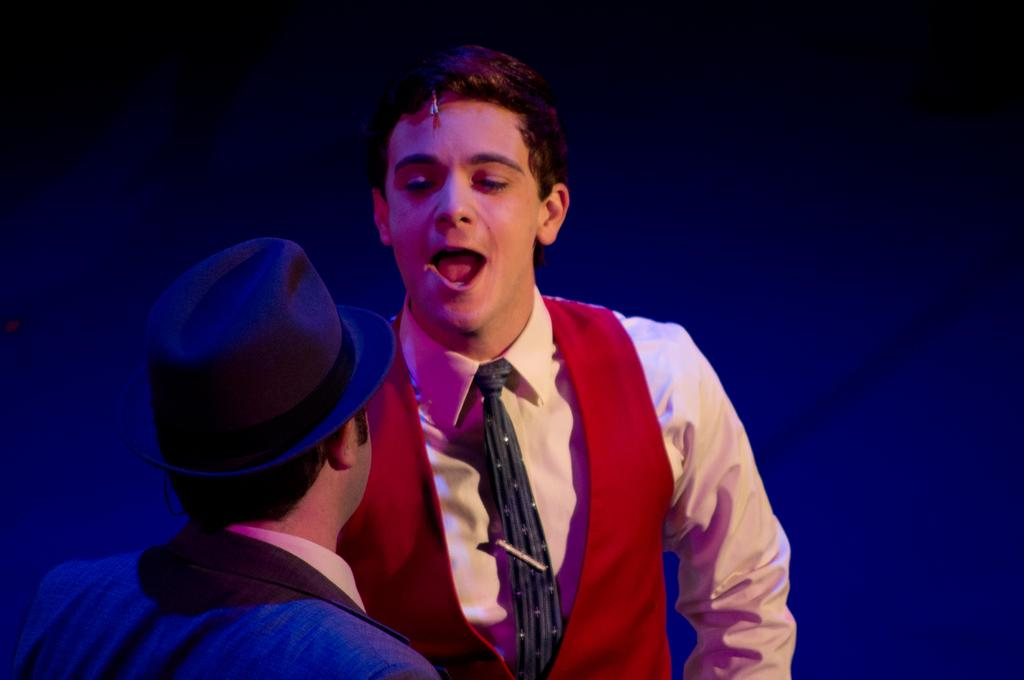How many persons are in the image? There are persons in the image. What are the persons wearing? The persons are wearing clothes. Can you describe the location of a specific person in the image? There is a person in the bottom left of the image. What is the person in the bottom left wearing on their head? The person in the bottom left is wearing a hat. What type of clam is being used as a hat by the person in the bottom left of the image? There is no clam present in the image, and the person in the bottom left is wearing a hat, not a clam. 